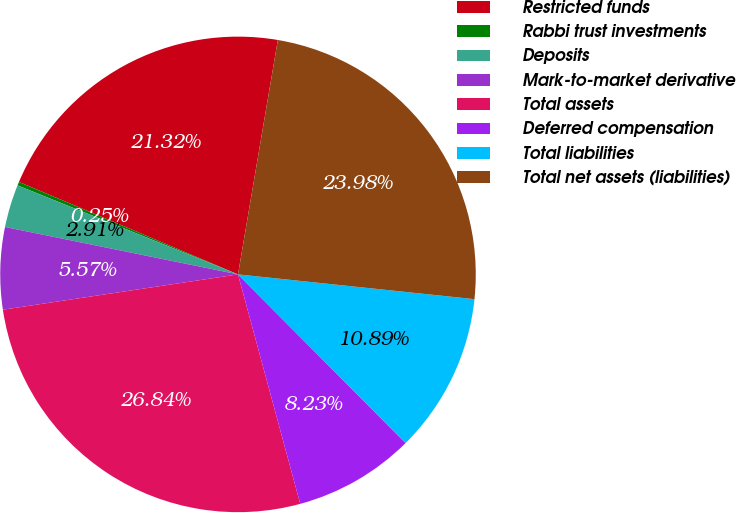Convert chart to OTSL. <chart><loc_0><loc_0><loc_500><loc_500><pie_chart><fcel>Restricted funds<fcel>Rabbi trust investments<fcel>Deposits<fcel>Mark-to-market derivative<fcel>Total assets<fcel>Deferred compensation<fcel>Total liabilities<fcel>Total net assets (liabilities)<nl><fcel>21.32%<fcel>0.25%<fcel>2.91%<fcel>5.57%<fcel>26.84%<fcel>8.23%<fcel>10.89%<fcel>23.98%<nl></chart> 